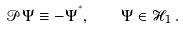<formula> <loc_0><loc_0><loc_500><loc_500>\mathcal { P } \Psi \equiv - \Psi ^ { ^ { * } } , \quad \Psi \in \mathcal { H } _ { 1 } \, .</formula> 